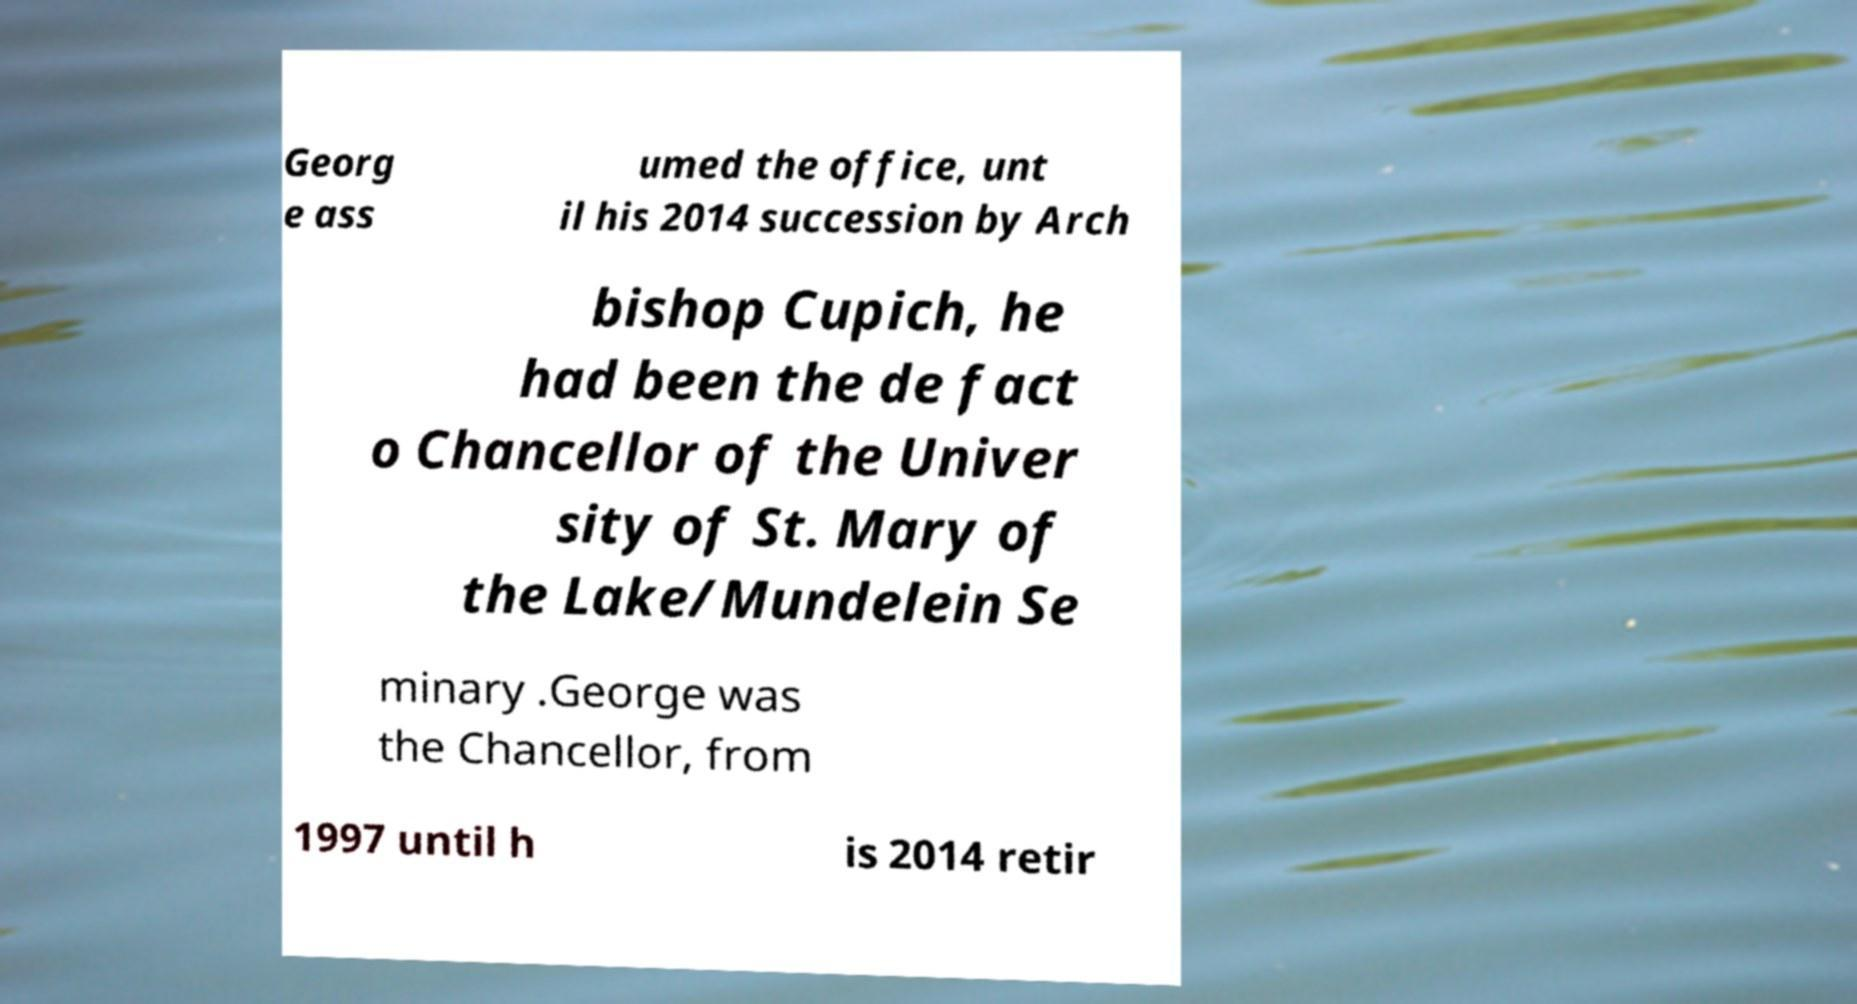For documentation purposes, I need the text within this image transcribed. Could you provide that? Georg e ass umed the office, unt il his 2014 succession by Arch bishop Cupich, he had been the de fact o Chancellor of the Univer sity of St. Mary of the Lake/Mundelein Se minary .George was the Chancellor, from 1997 until h is 2014 retir 